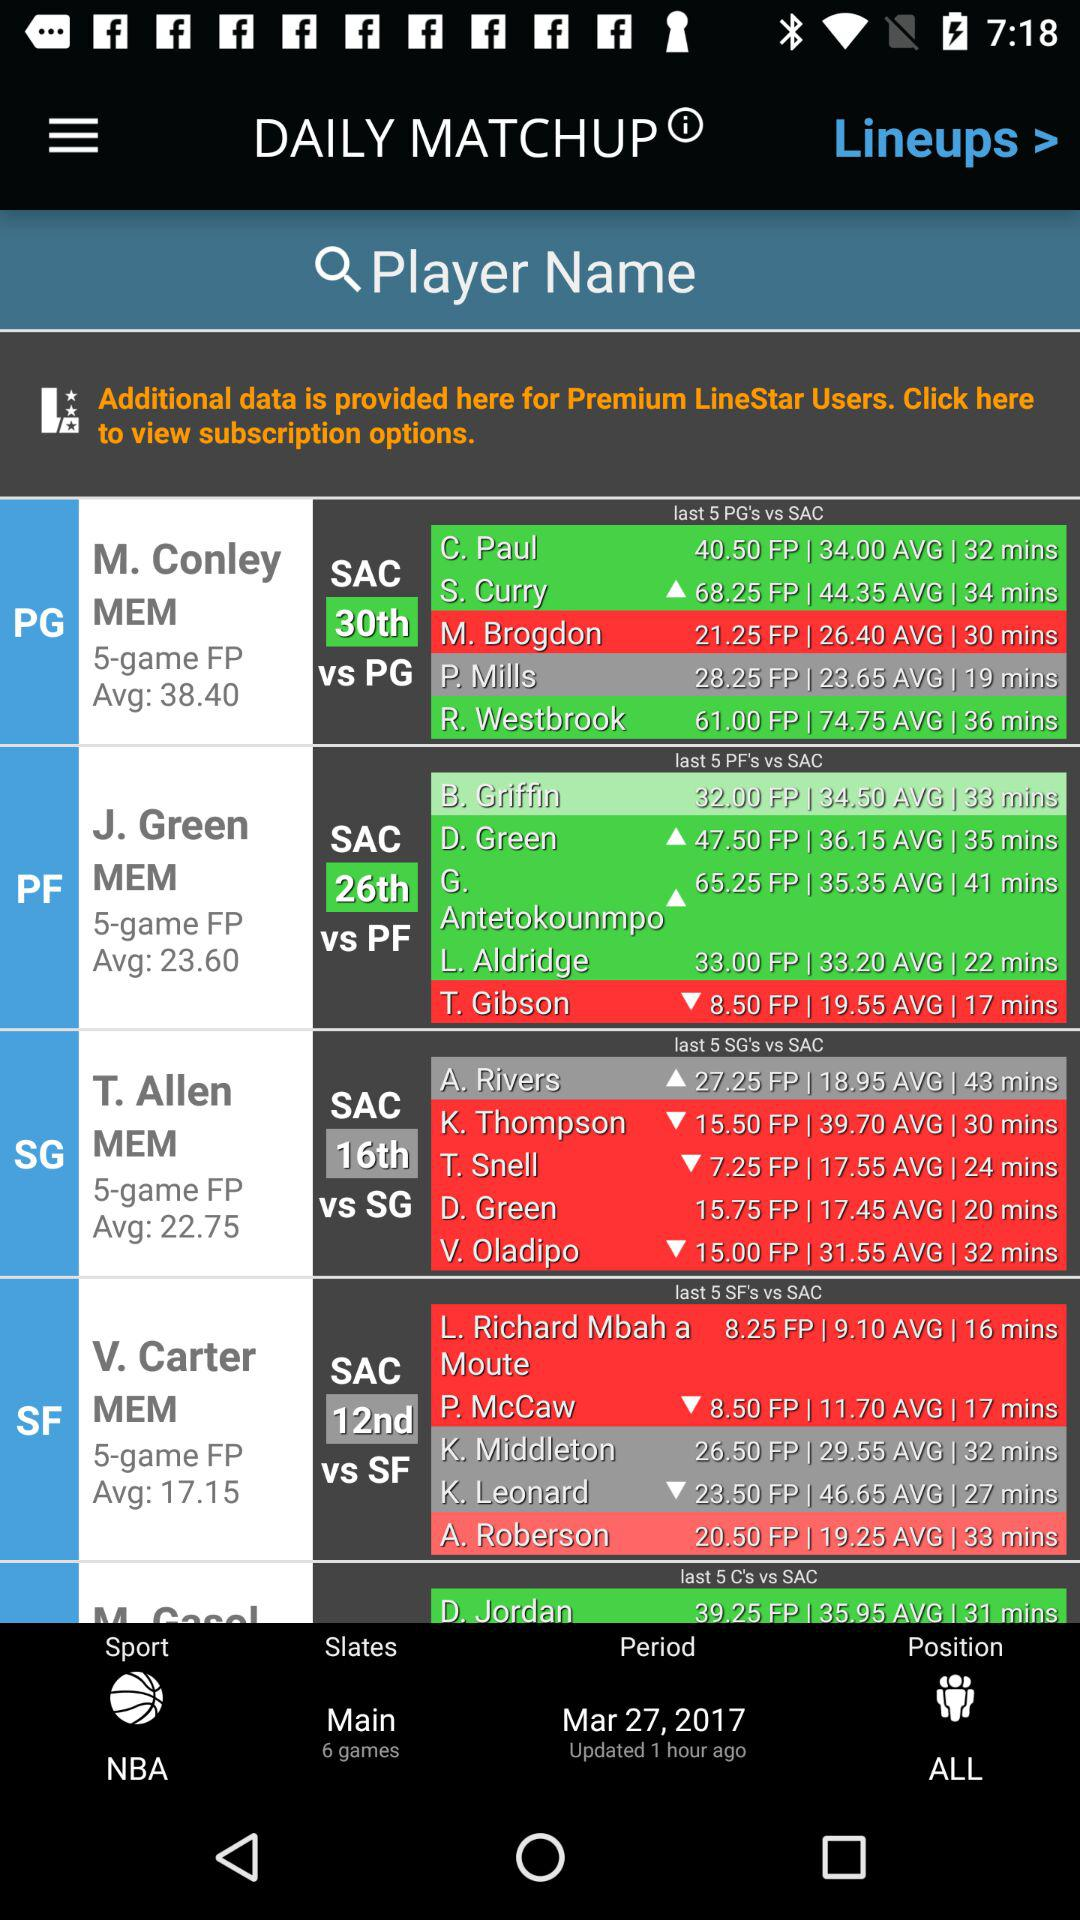What is the name of the players in SAC vs PG? The name of players are "C. Paul", "S. Curry", "M. Brogdon", "P. Mills" and "R. Westbrook". 